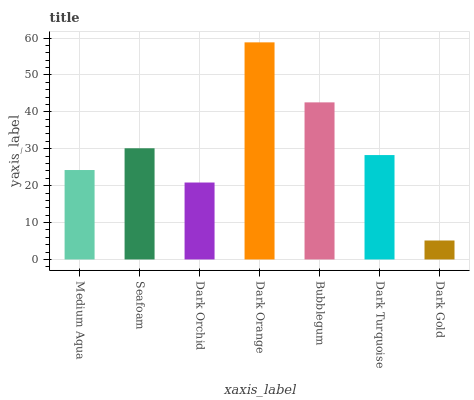Is Dark Gold the minimum?
Answer yes or no. Yes. Is Dark Orange the maximum?
Answer yes or no. Yes. Is Seafoam the minimum?
Answer yes or no. No. Is Seafoam the maximum?
Answer yes or no. No. Is Seafoam greater than Medium Aqua?
Answer yes or no. Yes. Is Medium Aqua less than Seafoam?
Answer yes or no. Yes. Is Medium Aqua greater than Seafoam?
Answer yes or no. No. Is Seafoam less than Medium Aqua?
Answer yes or no. No. Is Dark Turquoise the high median?
Answer yes or no. Yes. Is Dark Turquoise the low median?
Answer yes or no. Yes. Is Dark Gold the high median?
Answer yes or no. No. Is Dark Orange the low median?
Answer yes or no. No. 